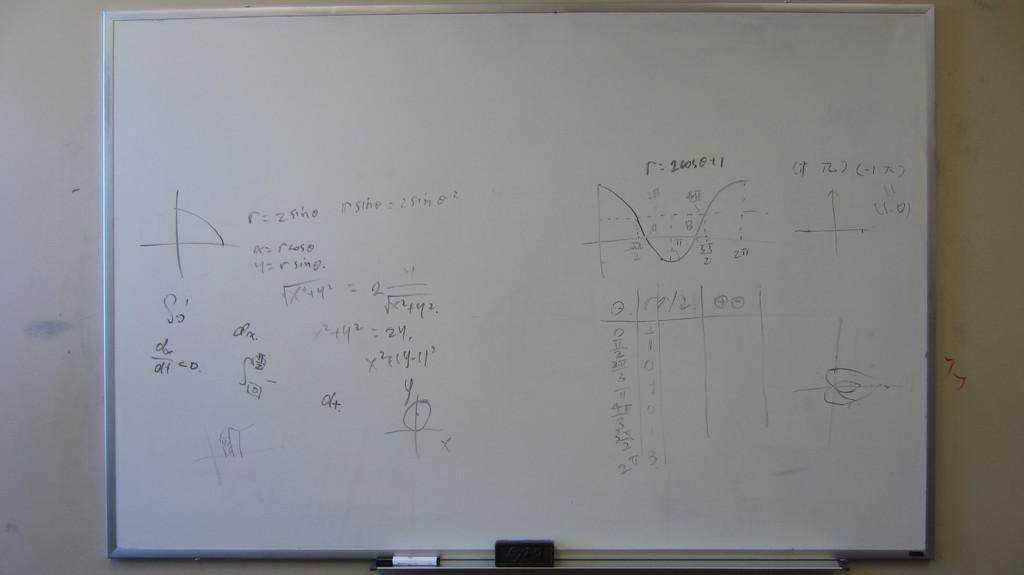<image>
Offer a succinct explanation of the picture presented. A white board has equations that involve sin and solving for r. 